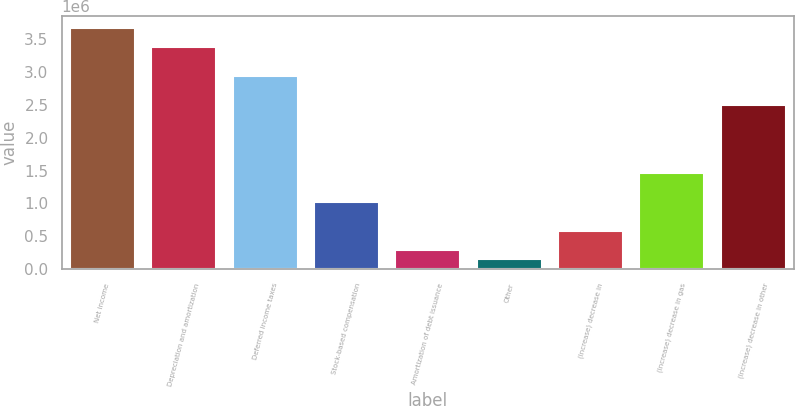Convert chart. <chart><loc_0><loc_0><loc_500><loc_500><bar_chart><fcel>Net income<fcel>Depreciation and amortization<fcel>Deferred income taxes<fcel>Stock-based compensation<fcel>Amortization of debt issuance<fcel>Other<fcel>(Increase) decrease in<fcel>(Increase) decrease in gas<fcel>(Increase) decrease in other<nl><fcel>3.66448e+06<fcel>3.37156e+06<fcel>2.93218e+06<fcel>1.02821e+06<fcel>295918<fcel>149459<fcel>588836<fcel>1.46759e+06<fcel>2.4928e+06<nl></chart> 